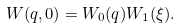Convert formula to latex. <formula><loc_0><loc_0><loc_500><loc_500>W ( { q } , 0 ) = W _ { 0 } ( { q } ) W _ { 1 } ( \xi ) .</formula> 